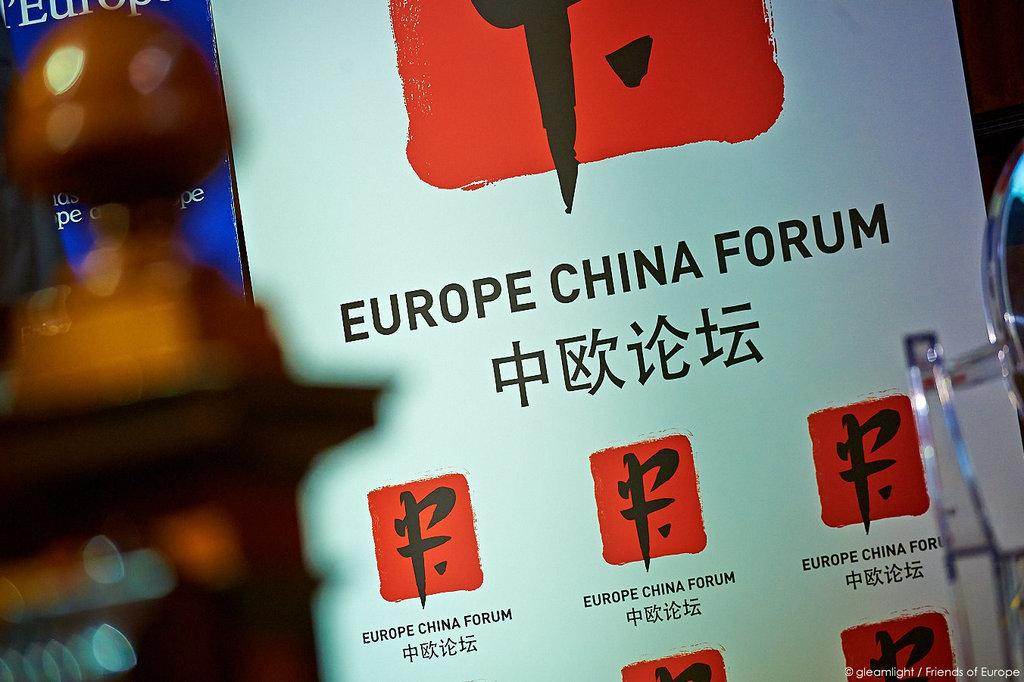<image>
Present a compact description of the photo's key features. a Europe China forum line on a white surface 